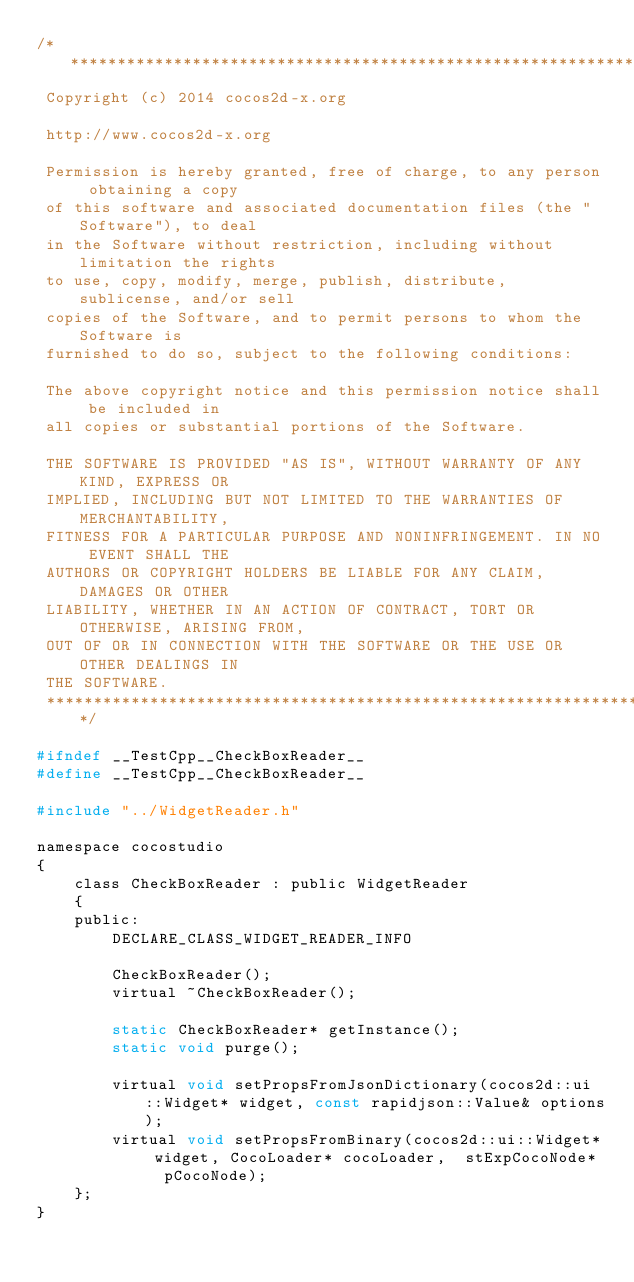Convert code to text. <code><loc_0><loc_0><loc_500><loc_500><_C_>/****************************************************************************
 Copyright (c) 2014 cocos2d-x.org
 
 http://www.cocos2d-x.org
 
 Permission is hereby granted, free of charge, to any person obtaining a copy
 of this software and associated documentation files (the "Software"), to deal
 in the Software without restriction, including without limitation the rights
 to use, copy, modify, merge, publish, distribute, sublicense, and/or sell
 copies of the Software, and to permit persons to whom the Software is
 furnished to do so, subject to the following conditions:
 
 The above copyright notice and this permission notice shall be included in
 all copies or substantial portions of the Software.
 
 THE SOFTWARE IS PROVIDED "AS IS", WITHOUT WARRANTY OF ANY KIND, EXPRESS OR
 IMPLIED, INCLUDING BUT NOT LIMITED TO THE WARRANTIES OF MERCHANTABILITY,
 FITNESS FOR A PARTICULAR PURPOSE AND NONINFRINGEMENT. IN NO EVENT SHALL THE
 AUTHORS OR COPYRIGHT HOLDERS BE LIABLE FOR ANY CLAIM, DAMAGES OR OTHER
 LIABILITY, WHETHER IN AN ACTION OF CONTRACT, TORT OR OTHERWISE, ARISING FROM,
 OUT OF OR IN CONNECTION WITH THE SOFTWARE OR THE USE OR OTHER DEALINGS IN
 THE SOFTWARE.
 ****************************************************************************/

#ifndef __TestCpp__CheckBoxReader__
#define __TestCpp__CheckBoxReader__

#include "../WidgetReader.h"

namespace cocostudio
{
    class CheckBoxReader : public WidgetReader
    {
    public:
        DECLARE_CLASS_WIDGET_READER_INFO
        
        CheckBoxReader();
        virtual ~CheckBoxReader();
        
        static CheckBoxReader* getInstance();
        static void purge();
        
        virtual void setPropsFromJsonDictionary(cocos2d::ui::Widget* widget, const rapidjson::Value& options);
        virtual void setPropsFromBinary(cocos2d::ui::Widget* widget, CocoLoader* cocoLoader,  stExpCocoNode*	pCocoNode);
    };
}
</code> 